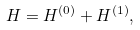Convert formula to latex. <formula><loc_0><loc_0><loc_500><loc_500>H = H ^ { ( 0 ) } + H ^ { ( 1 ) } ,</formula> 